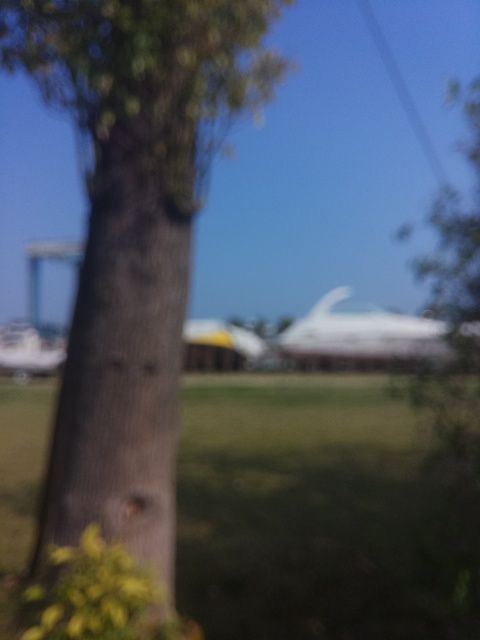What kind of mood does this image evoke? The image's blurriness and the visible soft lighting can evoke a sense of mystery or tranquility, possibly reflecting a calm, serene environment, or a moment captured in haste. 